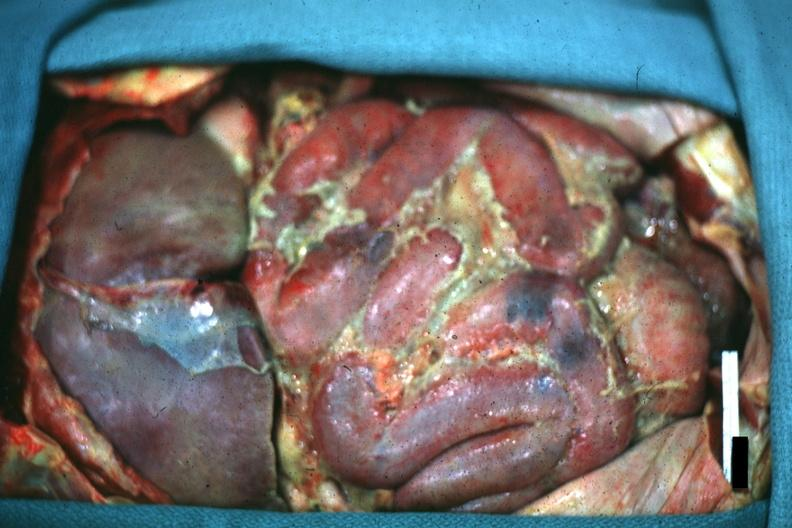what is present?
Answer the question using a single word or phrase. Abdomen 